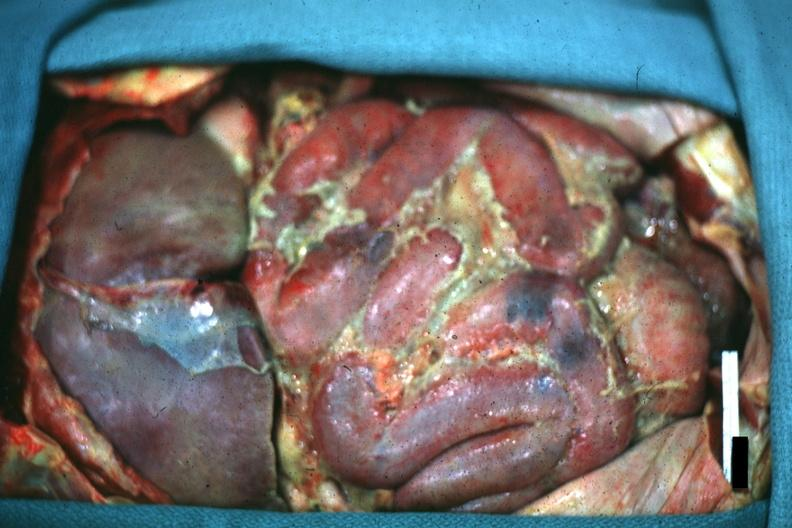what is present?
Answer the question using a single word or phrase. Abdomen 